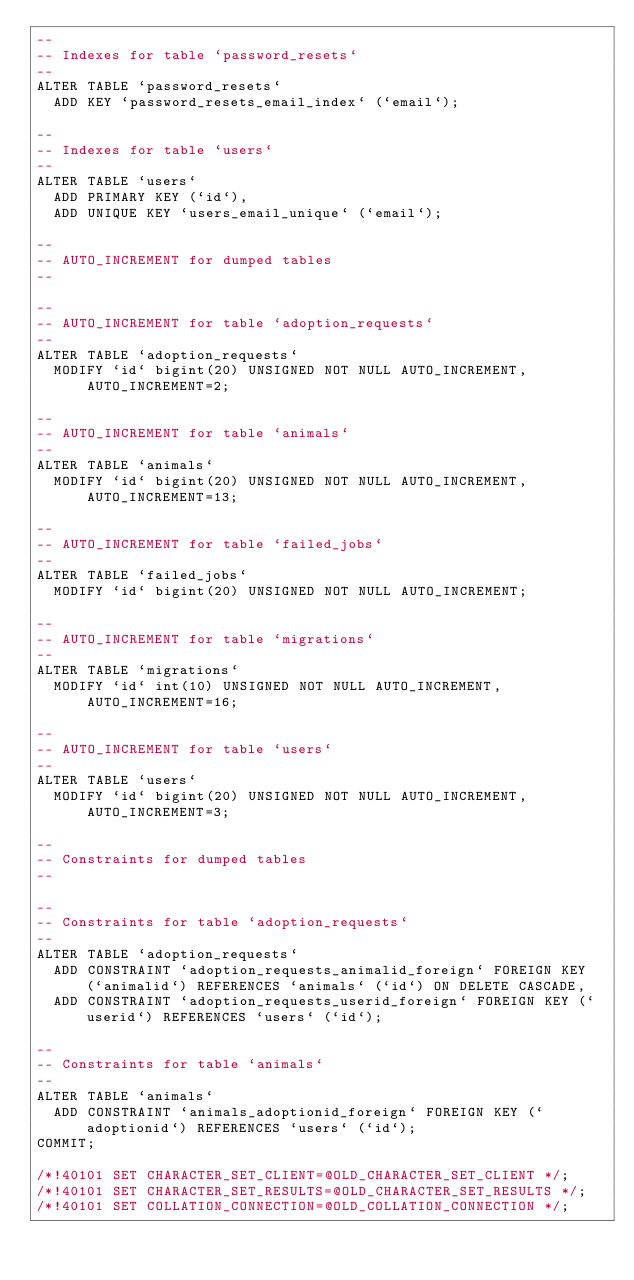<code> <loc_0><loc_0><loc_500><loc_500><_SQL_>--
-- Indexes for table `password_resets`
--
ALTER TABLE `password_resets`
  ADD KEY `password_resets_email_index` (`email`);

--
-- Indexes for table `users`
--
ALTER TABLE `users`
  ADD PRIMARY KEY (`id`),
  ADD UNIQUE KEY `users_email_unique` (`email`);

--
-- AUTO_INCREMENT for dumped tables
--

--
-- AUTO_INCREMENT for table `adoption_requests`
--
ALTER TABLE `adoption_requests`
  MODIFY `id` bigint(20) UNSIGNED NOT NULL AUTO_INCREMENT, AUTO_INCREMENT=2;

--
-- AUTO_INCREMENT for table `animals`
--
ALTER TABLE `animals`
  MODIFY `id` bigint(20) UNSIGNED NOT NULL AUTO_INCREMENT, AUTO_INCREMENT=13;

--
-- AUTO_INCREMENT for table `failed_jobs`
--
ALTER TABLE `failed_jobs`
  MODIFY `id` bigint(20) UNSIGNED NOT NULL AUTO_INCREMENT;

--
-- AUTO_INCREMENT for table `migrations`
--
ALTER TABLE `migrations`
  MODIFY `id` int(10) UNSIGNED NOT NULL AUTO_INCREMENT, AUTO_INCREMENT=16;

--
-- AUTO_INCREMENT for table `users`
--
ALTER TABLE `users`
  MODIFY `id` bigint(20) UNSIGNED NOT NULL AUTO_INCREMENT, AUTO_INCREMENT=3;

--
-- Constraints for dumped tables
--

--
-- Constraints for table `adoption_requests`
--
ALTER TABLE `adoption_requests`
  ADD CONSTRAINT `adoption_requests_animalid_foreign` FOREIGN KEY (`animalid`) REFERENCES `animals` (`id`) ON DELETE CASCADE,
  ADD CONSTRAINT `adoption_requests_userid_foreign` FOREIGN KEY (`userid`) REFERENCES `users` (`id`);

--
-- Constraints for table `animals`
--
ALTER TABLE `animals`
  ADD CONSTRAINT `animals_adoptionid_foreign` FOREIGN KEY (`adoptionid`) REFERENCES `users` (`id`);
COMMIT;

/*!40101 SET CHARACTER_SET_CLIENT=@OLD_CHARACTER_SET_CLIENT */;
/*!40101 SET CHARACTER_SET_RESULTS=@OLD_CHARACTER_SET_RESULTS */;
/*!40101 SET COLLATION_CONNECTION=@OLD_COLLATION_CONNECTION */;
</code> 